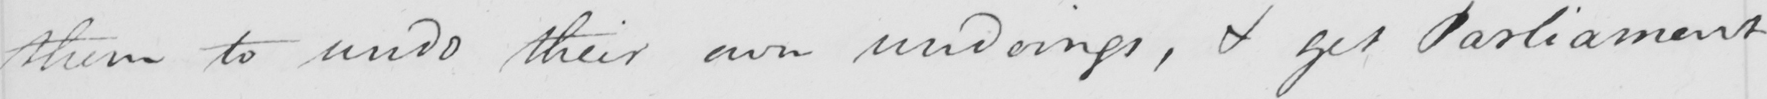What text is written in this handwritten line? them to undo their own undoings , & get Parliament 